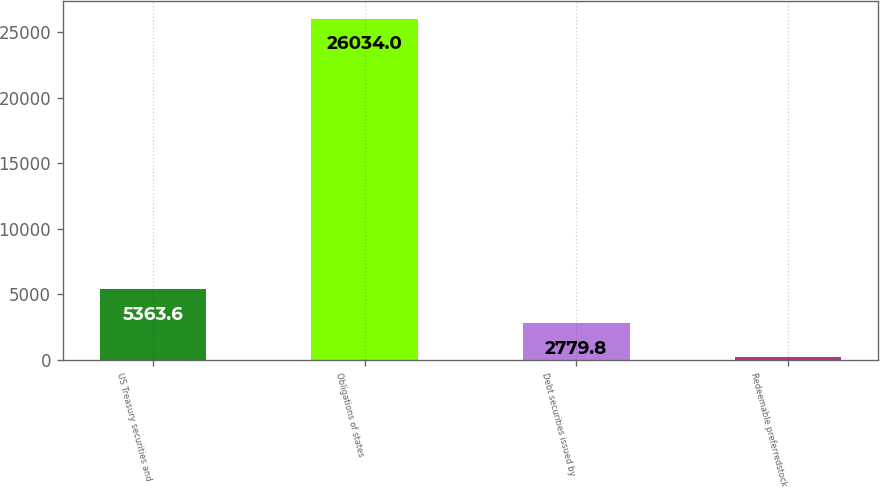Convert chart to OTSL. <chart><loc_0><loc_0><loc_500><loc_500><bar_chart><fcel>US Treasury securities and<fcel>Obligations of states<fcel>Debt securities issued by<fcel>Redeemable preferredstock<nl><fcel>5363.6<fcel>26034<fcel>2779.8<fcel>196<nl></chart> 